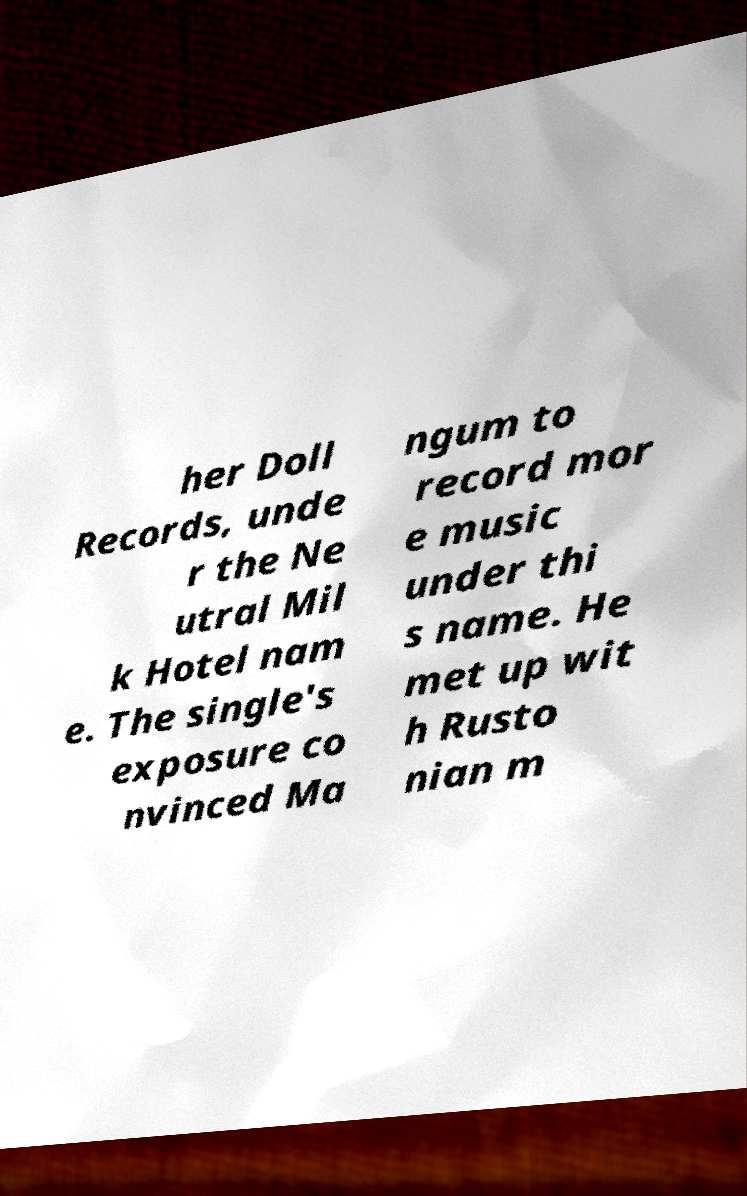I need the written content from this picture converted into text. Can you do that? her Doll Records, unde r the Ne utral Mil k Hotel nam e. The single's exposure co nvinced Ma ngum to record mor e music under thi s name. He met up wit h Rusto nian m 